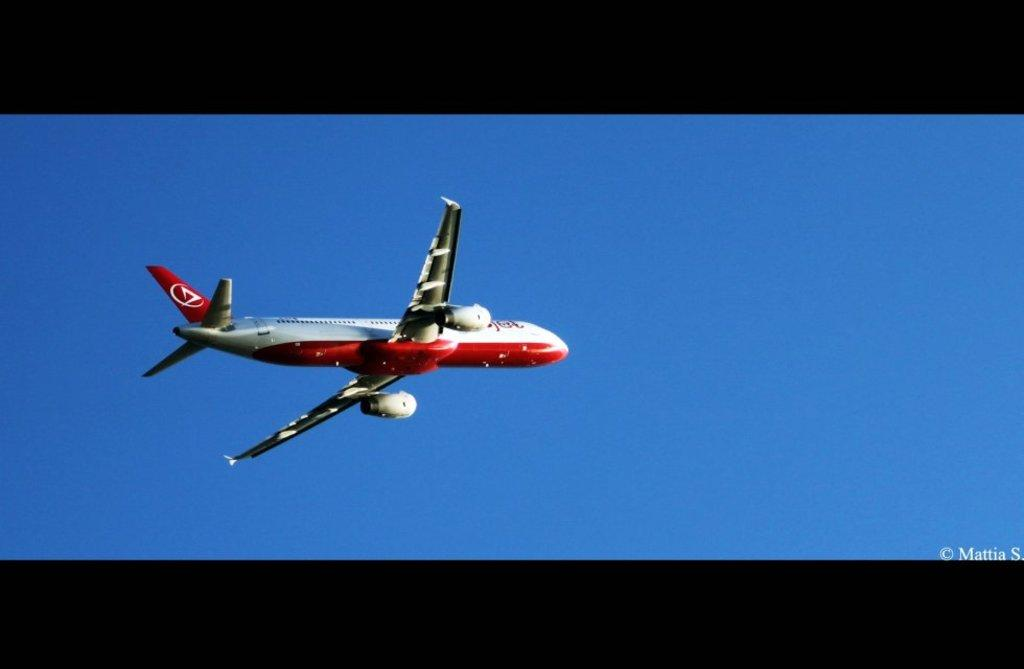What is the main subject of the image? The main subject of the image is an airplane. What is the airplane doing in the image? The airplane is flying in the sky. What rule does the airplane break in the image? There is no indication in the image that the airplane is breaking any rules. What songs can be heard coming from the airplane in the image? There is no audio component in the image, so it's not possible to determine what songs might be heard. 